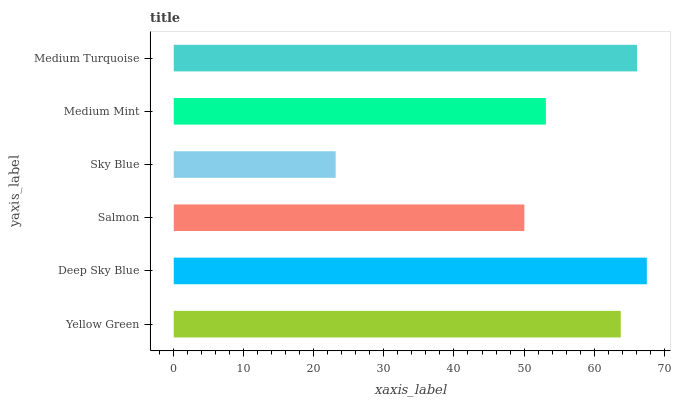Is Sky Blue the minimum?
Answer yes or no. Yes. Is Deep Sky Blue the maximum?
Answer yes or no. Yes. Is Salmon the minimum?
Answer yes or no. No. Is Salmon the maximum?
Answer yes or no. No. Is Deep Sky Blue greater than Salmon?
Answer yes or no. Yes. Is Salmon less than Deep Sky Blue?
Answer yes or no. Yes. Is Salmon greater than Deep Sky Blue?
Answer yes or no. No. Is Deep Sky Blue less than Salmon?
Answer yes or no. No. Is Yellow Green the high median?
Answer yes or no. Yes. Is Medium Mint the low median?
Answer yes or no. Yes. Is Salmon the high median?
Answer yes or no. No. Is Salmon the low median?
Answer yes or no. No. 